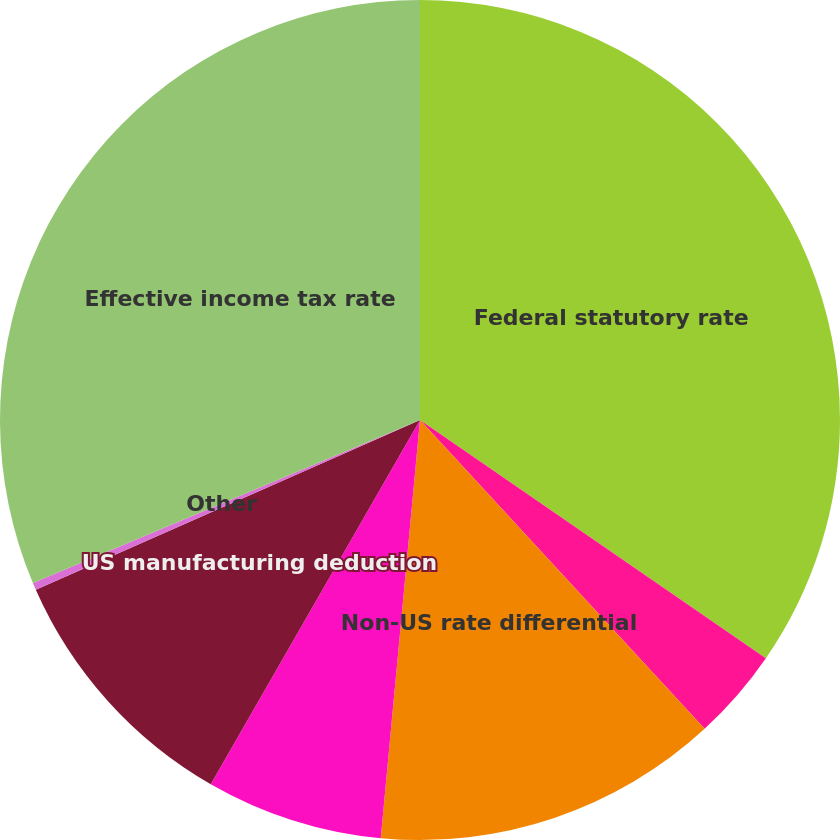Convert chart. <chart><loc_0><loc_0><loc_500><loc_500><pie_chart><fcel>Federal statutory rate<fcel>State and local taxes net of<fcel>Non-US rate differential<fcel>Non-US tax holidays<fcel>US manufacturing deduction<fcel>Other<fcel>Effective income tax rate<nl><fcel>34.6%<fcel>3.55%<fcel>13.34%<fcel>6.81%<fcel>10.08%<fcel>0.28%<fcel>31.34%<nl></chart> 